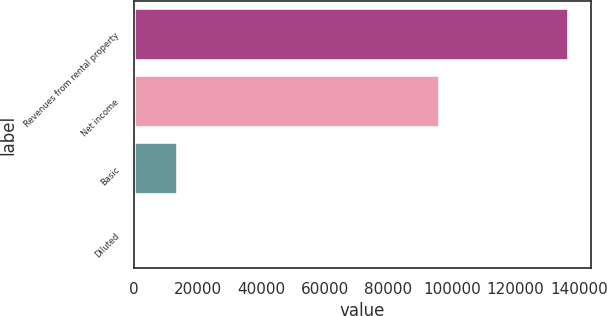<chart> <loc_0><loc_0><loc_500><loc_500><bar_chart><fcel>Revenues from rental property<fcel>Net income<fcel>Basic<fcel>Diluted<nl><fcel>136838<fcel>96195<fcel>13684.2<fcel>0.4<nl></chart> 